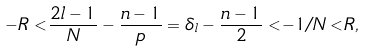Convert formula to latex. <formula><loc_0><loc_0><loc_500><loc_500>- R < \frac { 2 l - 1 } { N } - \frac { n - 1 } { p } = \delta _ { l } - \frac { n - 1 } { 2 } < - 1 / N < R ,</formula> 